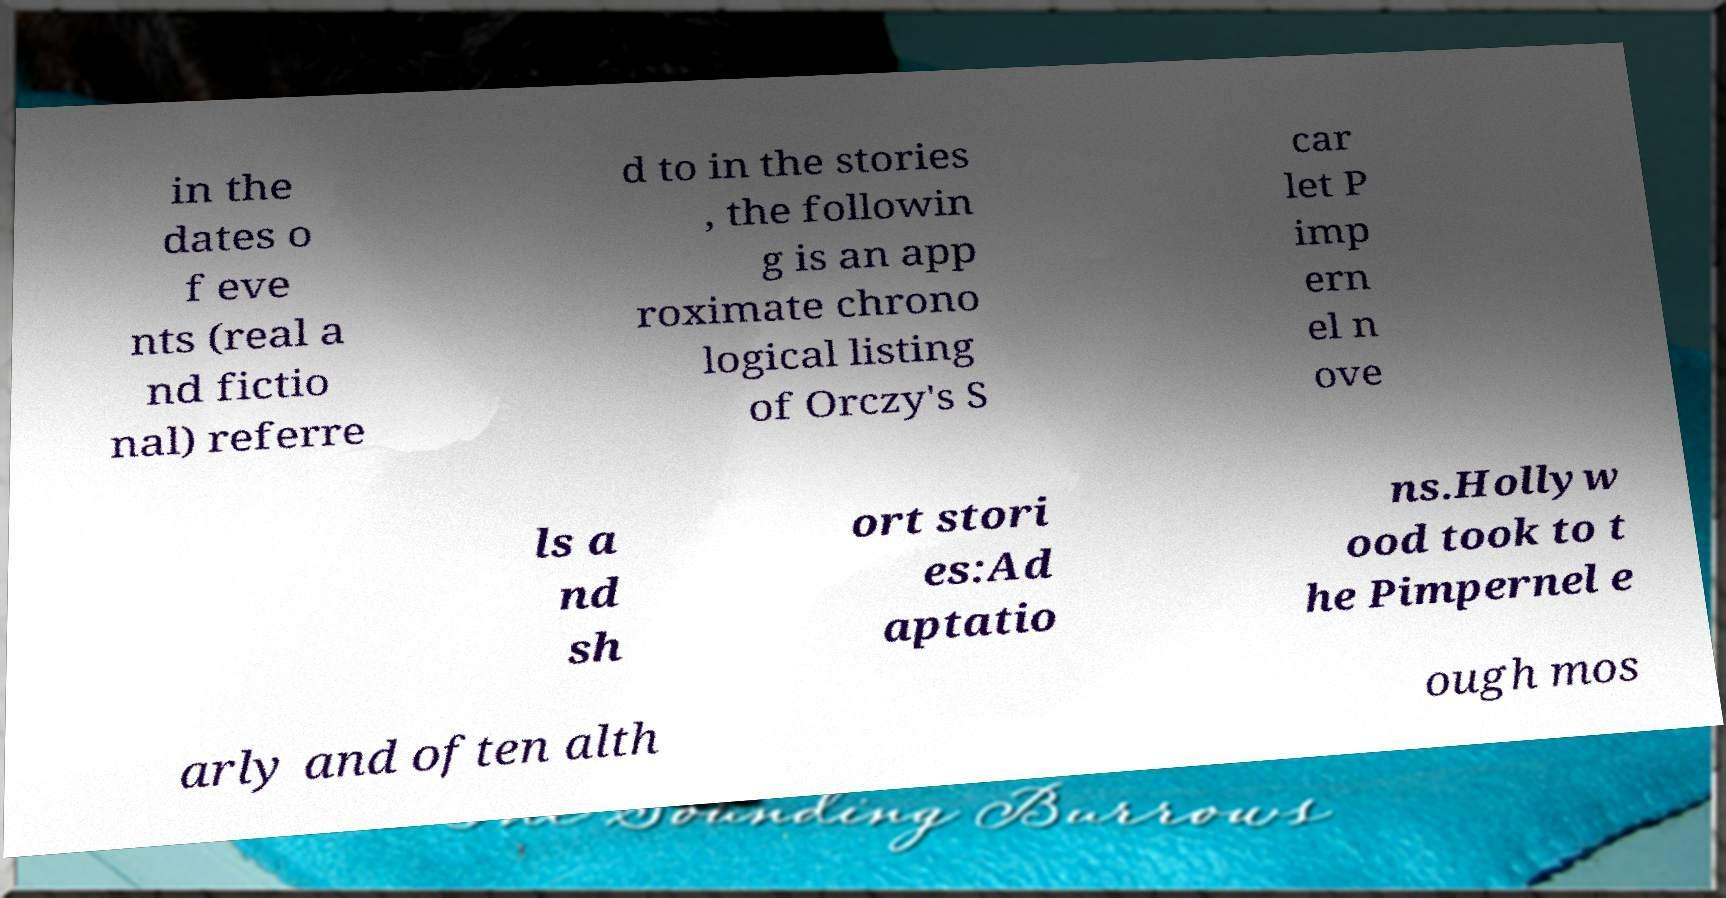There's text embedded in this image that I need extracted. Can you transcribe it verbatim? in the dates o f eve nts (real a nd fictio nal) referre d to in the stories , the followin g is an app roximate chrono logical listing of Orczy's S car let P imp ern el n ove ls a nd sh ort stori es:Ad aptatio ns.Hollyw ood took to t he Pimpernel e arly and often alth ough mos 